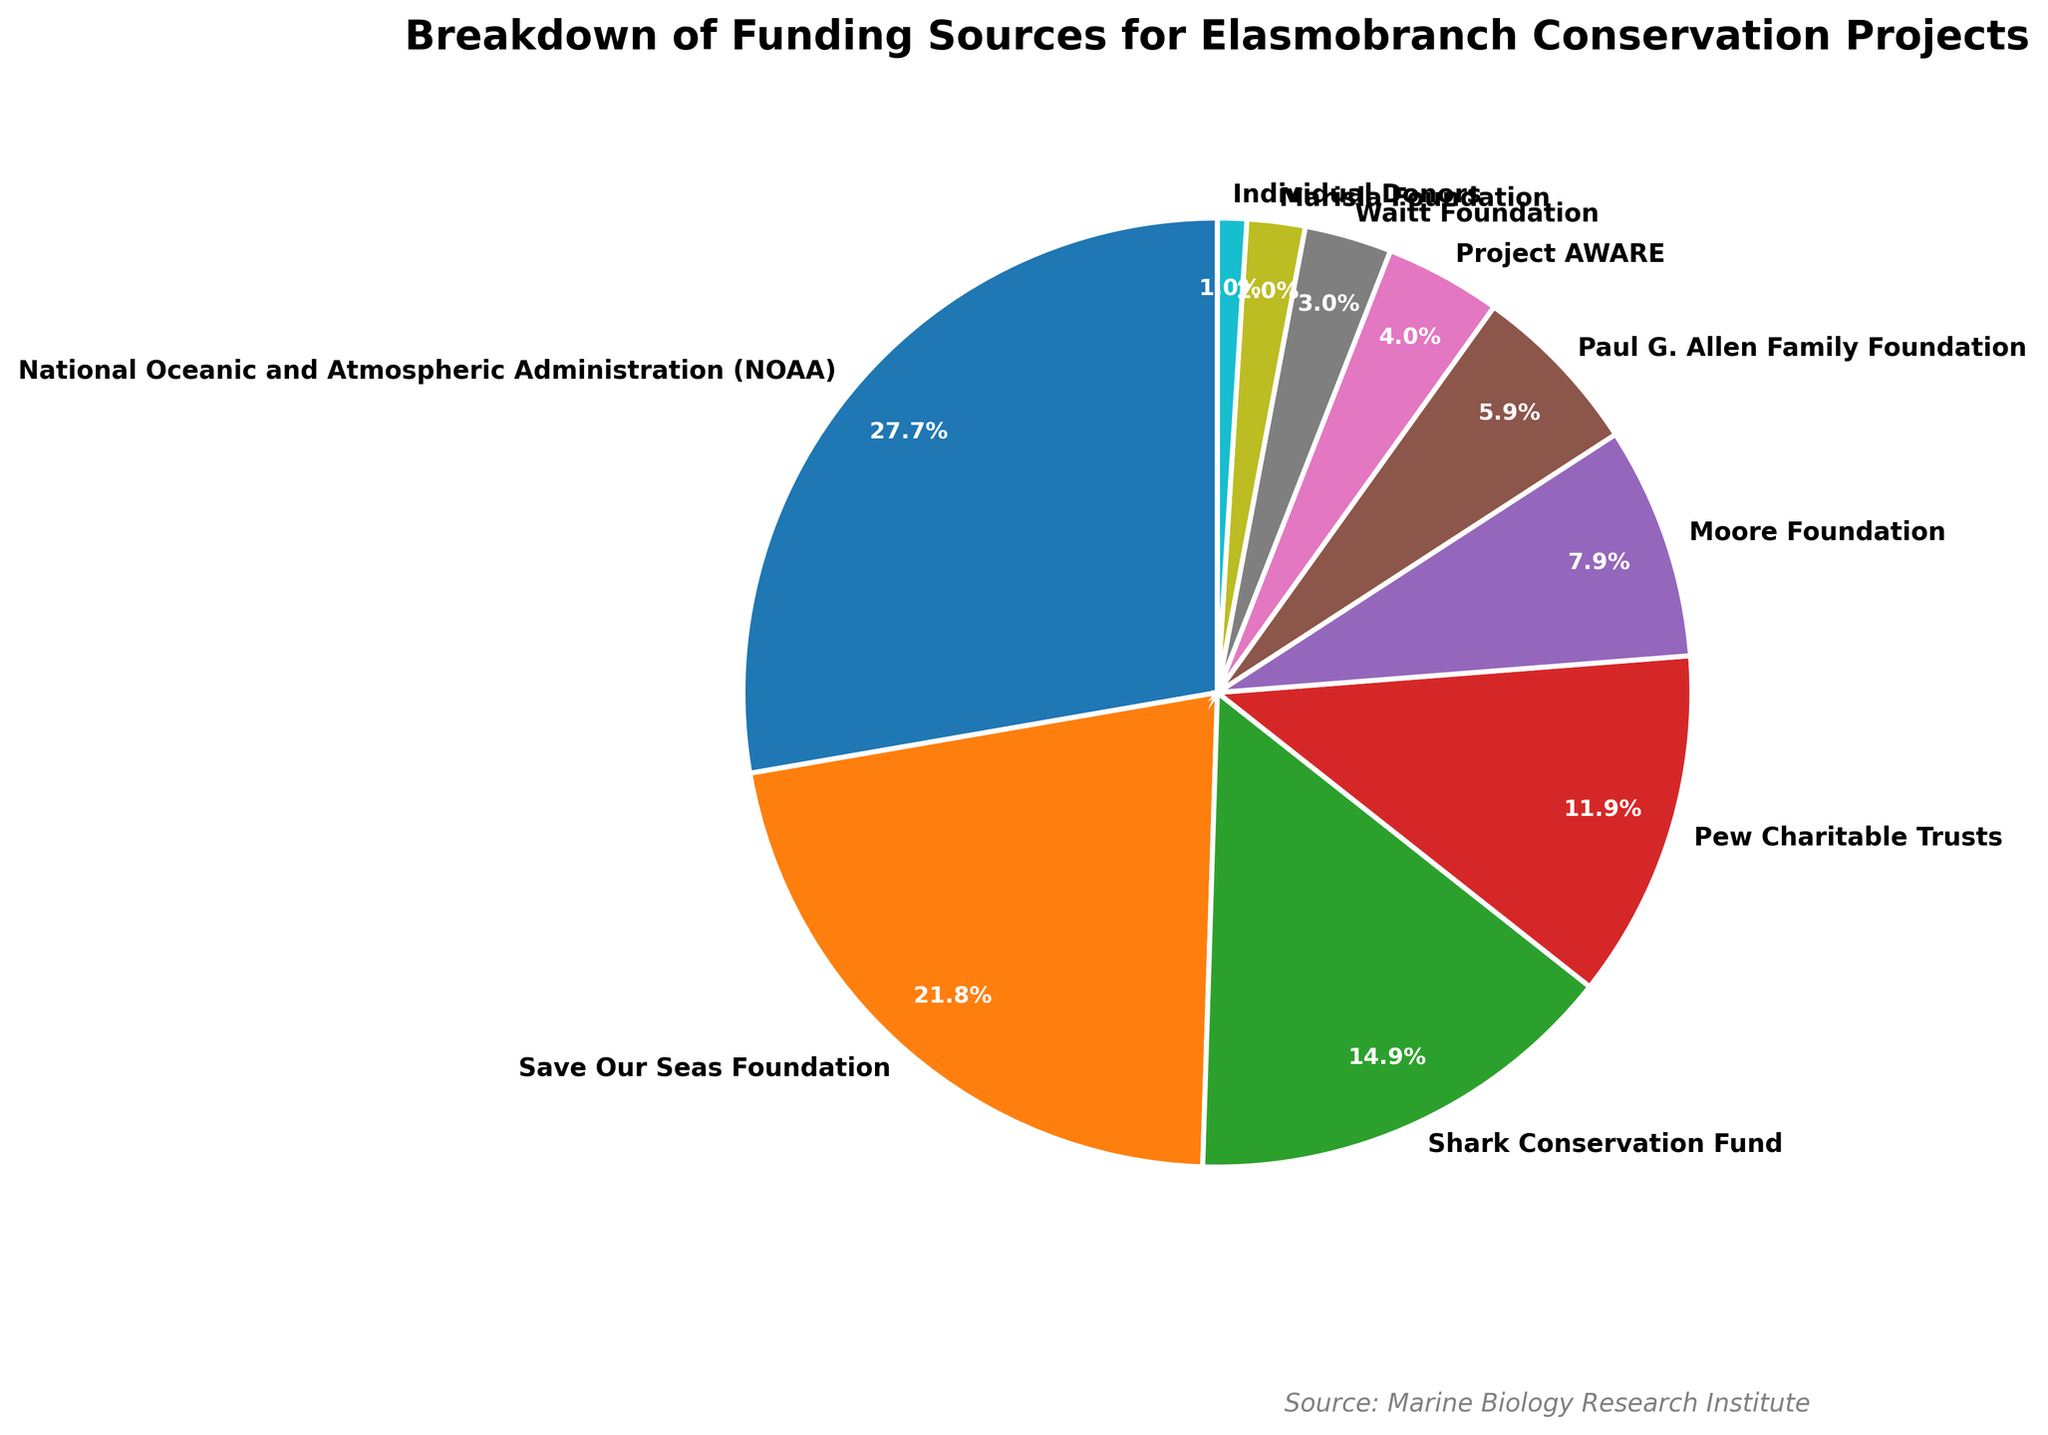Which funding source contributes the largest percentage to elasmobranch conservation projects? Look at the section size and the associated percentage label on the pie chart; the largest section and percentage belongs to the National Oceanic and Atmospheric Administration (NOAA) with 28%.
Answer: National Oceanic and Atmospheric Administration (NOAA) What is the combined percentage of funding from Shark Conservation Fund and Pew Charitable Trusts? Add the percentages of funding from Shark Conservation Fund (15%) and Pew Charitable Trusts (12%). So, 15 + 12 = 27%.
Answer: 27% Which funding source contributes the smallest percentage and what is that percentage? Identify the smallest section in the pie chart and read its label; Individual Donors contribute the smallest percentage which is 1%.
Answer: Individual Donors, 1% How much more does Save Our Seas Foundation contribute compared to Moore Foundation? Subtract Moore Foundation's percentage (8%) from Save Our Seas Foundation's percentage (22%), which gives 22 - 8 = 14%.
Answer: 14% If we were to group the contributions from Pew Charitable Trusts, Moore Foundation, and Paul G. Allen Family Foundation together, what would be their combined contribution percentage? Sum the percentages from Pew Charitable Trusts (12%), Moore Foundation (8%), and Paul G. Allen Family Foundation (6%). Thus, 12 + 8 + 6 = 26%.
Answer: 26% Which two funding sources have the most similar contribution percentages and what are those percentages? Look for the sections in the pie chart with the closest values. Pew Charitable Trusts (12%) and Moore Foundation (8%) have values that are closer compared to other pairs.
Answer: Pew Charitable Trusts (12%) and Moore Foundation (8%) Considering only the contributions greater than 10%, what is the total combined percentage? Identify and sum contributions greater than 10%: NOAA (28%), Save Our Seas Foundation (22%), Shark Conservation Fund (15%), and Pew Charitable Trusts (12%). Thus, 28 + 22 + 15 + 12 = 77%.
Answer: 77% Which color represents funding from Project AWARE? Identify the section labeled "Project AWARE" in the pie chart and note its color, which is shown as gray.
Answer: Gray Order the funding sources by their percentages in descending order. Arrange the funding sources based on their given percentages from largest to smallest: NOAA (28%), Save Our Seas Foundation (22%), Shark Conservation Fund (15%), Pew Charitable Trusts (12%), Moore Foundation (8%), Paul G. Allen Family Foundation (6%), Project AWARE (4%), Waitt Foundation (3%), Marisla Foundation (2%), Individual Donors (1%).
Answer: NOAA, Save Our Seas Foundation, Shark Conservation Fund, Pew Charitable Trusts, Moore Foundation, Paul G. Allen Family Foundation, Project AWARE, Waitt Foundation, Marisla Foundation, Individual Donors If the contributions from Individual Donors and Marisla Foundation were doubled, what would be their new combined percentage? Calculate the doubled percentage for both: Individual Donors (1% * 2 = 2%), Marisla Foundation (2% * 2 = 4%), then sum them up: 2 + 4 = 6%.
Answer: 6% 